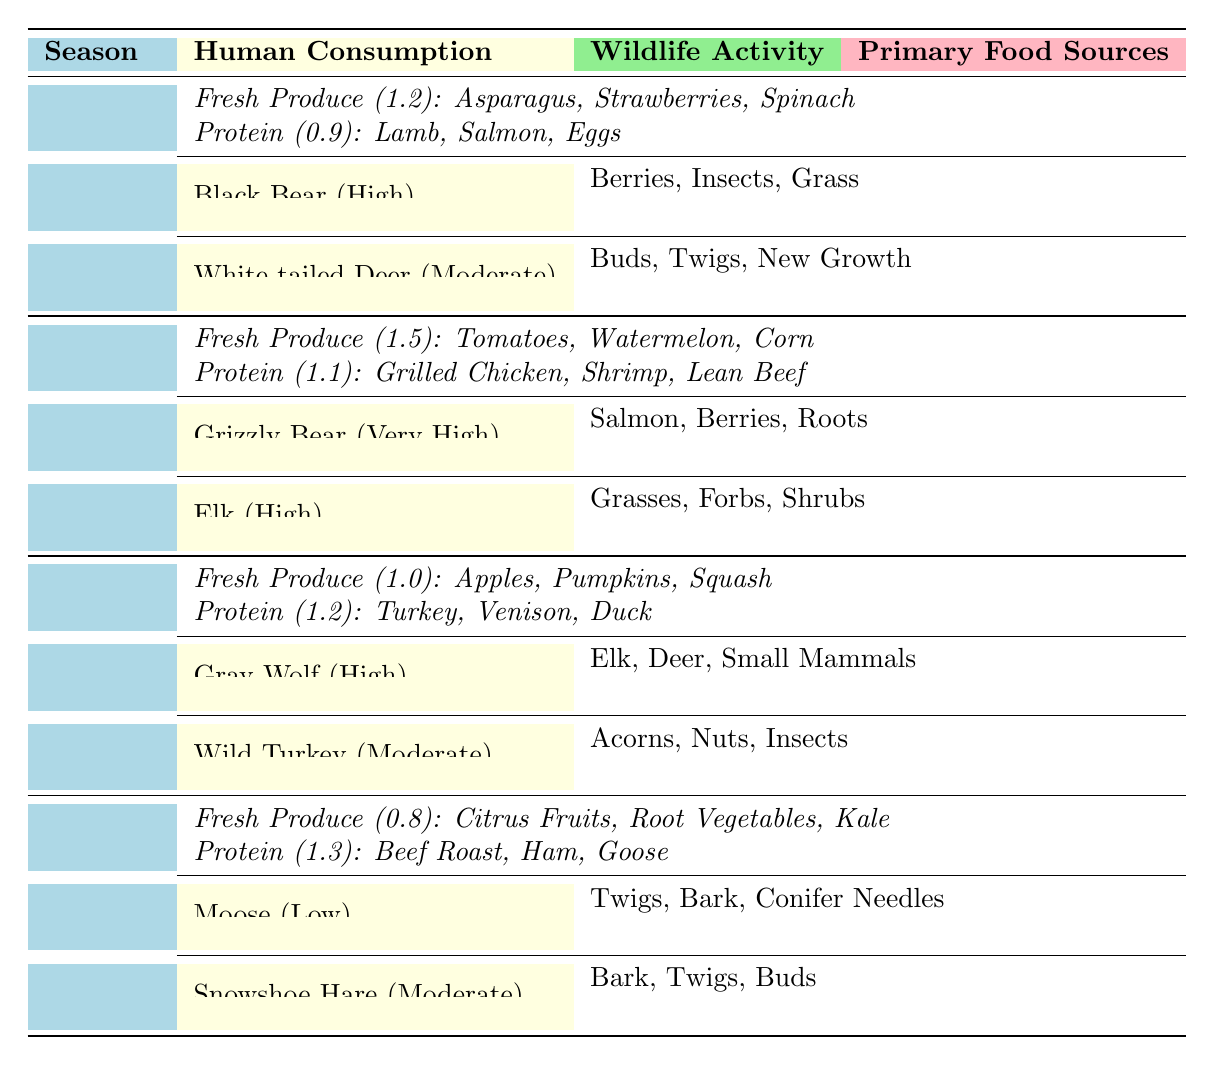What is the highest human food consumption rate in the table? The only rates of human food consumption are in Spring (1.2), Summer (1.5), Fall (1.0), and Winter (0.8). The maximum value is 1.5 in Summer.
Answer: 1.5 Which wildlife species has the highest activity level? The activity levels listed are "High," "Very High," and "Low." Grizzly Bear shows the highest activity level with "Very High."
Answer: Grizzly Bear In which season is protein consumption the highest? Protein consumption rates in each season are: Spring (0.9), Summer (1.1), Fall (1.2), and Winter (1.3). The highest rate is in Winter at 1.3.
Answer: Winter How many wildlife species are active in Fall? In Fall, there are two wildlife species listed: Gray Wolf and Wild Turkey. Therefore, the count is 2.
Answer: 2 What are the primary food sources for Black Bear? According to the table, the primary food sources for Black Bear are Berries, Insects, and Grass.
Answer: Berries, Insects, Grass Is human food consumption higher in Spring or Fall? Spring has a consumption rate of 1.2, while Fall has 1.0. Since 1.2 is greater than 1.0, Spring has higher consumption.
Answer: Spring How does the average human food consumption in Summer compare to Winter? In Summer, consumption is 1.5, and in Winter, it is 0.8. The average of these two is (1.5 + 0.8)/2 = 1.15, making Summer greater than Winter.
Answer: Summer is greater What is the primary food source for the Grizzly Bear? The table states that Grizzly Bear's primary food sources are Salmon, Berries, and Roots.
Answer: Salmon, Berries, Roots Which season shows a noticeable increase in Fresh Produce consumption? Fresh Produce consumption goes from 1.2 in Spring to 1.5 in Summer, indicating a notable increase.
Answer: Summer Do Moose have high or low activity levels in winter? Moose are listed with a "Low" activity level in Winter based on the table data.
Answer: Low What is the consumption rate difference between Fall and Winter for protein? Fall consumption for protein is 1.2, and Winter is 1.3. The difference is 1.3 - 1.2 = 0.1.
Answer: 0.1 Which wildlife species has a primary food source of Acorns? Wild Turkey is the species listed with Acorns as one of its primary food sources in Fall.
Answer: Wild Turkey 